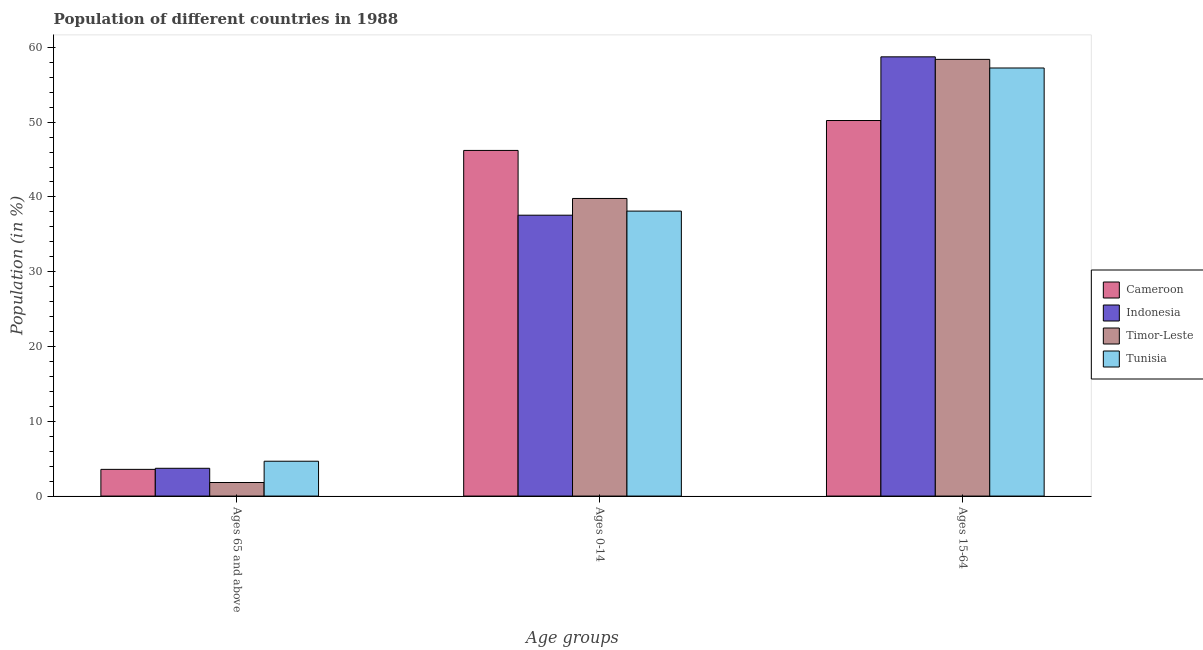How many different coloured bars are there?
Offer a very short reply. 4. How many groups of bars are there?
Offer a terse response. 3. How many bars are there on the 2nd tick from the left?
Ensure brevity in your answer.  4. What is the label of the 2nd group of bars from the left?
Offer a terse response. Ages 0-14. What is the percentage of population within the age-group 0-14 in Cameroon?
Your answer should be compact. 46.22. Across all countries, what is the maximum percentage of population within the age-group 0-14?
Provide a succinct answer. 46.22. Across all countries, what is the minimum percentage of population within the age-group of 65 and above?
Offer a very short reply. 1.81. In which country was the percentage of population within the age-group 15-64 maximum?
Offer a terse response. Indonesia. What is the total percentage of population within the age-group 0-14 in the graph?
Provide a short and direct response. 161.67. What is the difference between the percentage of population within the age-group 0-14 in Indonesia and that in Timor-Leste?
Make the answer very short. -2.24. What is the difference between the percentage of population within the age-group 15-64 in Tunisia and the percentage of population within the age-group of 65 and above in Cameroon?
Your answer should be very brief. 53.67. What is the average percentage of population within the age-group of 65 and above per country?
Ensure brevity in your answer.  3.44. What is the difference between the percentage of population within the age-group 0-14 and percentage of population within the age-group 15-64 in Cameroon?
Provide a succinct answer. -4. What is the ratio of the percentage of population within the age-group 0-14 in Tunisia to that in Timor-Leste?
Offer a very short reply. 0.96. Is the percentage of population within the age-group 15-64 in Tunisia less than that in Indonesia?
Make the answer very short. Yes. What is the difference between the highest and the second highest percentage of population within the age-group 15-64?
Ensure brevity in your answer.  0.34. What is the difference between the highest and the lowest percentage of population within the age-group 15-64?
Your response must be concise. 8.52. Is the sum of the percentage of population within the age-group of 65 and above in Cameroon and Tunisia greater than the maximum percentage of population within the age-group 15-64 across all countries?
Offer a very short reply. No. What does the 4th bar from the left in Ages 0-14 represents?
Your response must be concise. Tunisia. What does the 2nd bar from the right in Ages 15-64 represents?
Provide a short and direct response. Timor-Leste. How many bars are there?
Your answer should be compact. 12. Does the graph contain grids?
Give a very brief answer. No. How are the legend labels stacked?
Offer a very short reply. Vertical. What is the title of the graph?
Your answer should be very brief. Population of different countries in 1988. Does "Upper middle income" appear as one of the legend labels in the graph?
Make the answer very short. No. What is the label or title of the X-axis?
Give a very brief answer. Age groups. What is the Population (in %) in Cameroon in Ages 65 and above?
Offer a very short reply. 3.57. What is the Population (in %) in Indonesia in Ages 65 and above?
Make the answer very short. 3.71. What is the Population (in %) of Timor-Leste in Ages 65 and above?
Your answer should be very brief. 1.81. What is the Population (in %) of Tunisia in Ages 65 and above?
Your answer should be very brief. 4.66. What is the Population (in %) of Cameroon in Ages 0-14?
Make the answer very short. 46.22. What is the Population (in %) of Indonesia in Ages 0-14?
Your response must be concise. 37.56. What is the Population (in %) in Timor-Leste in Ages 0-14?
Give a very brief answer. 39.79. What is the Population (in %) of Tunisia in Ages 0-14?
Your answer should be compact. 38.1. What is the Population (in %) of Cameroon in Ages 15-64?
Give a very brief answer. 50.21. What is the Population (in %) in Indonesia in Ages 15-64?
Keep it short and to the point. 58.73. What is the Population (in %) of Timor-Leste in Ages 15-64?
Your answer should be very brief. 58.39. What is the Population (in %) in Tunisia in Ages 15-64?
Make the answer very short. 57.24. Across all Age groups, what is the maximum Population (in %) in Cameroon?
Keep it short and to the point. 50.21. Across all Age groups, what is the maximum Population (in %) in Indonesia?
Provide a short and direct response. 58.73. Across all Age groups, what is the maximum Population (in %) in Timor-Leste?
Your answer should be compact. 58.39. Across all Age groups, what is the maximum Population (in %) in Tunisia?
Your answer should be very brief. 57.24. Across all Age groups, what is the minimum Population (in %) of Cameroon?
Provide a short and direct response. 3.57. Across all Age groups, what is the minimum Population (in %) of Indonesia?
Your answer should be compact. 3.71. Across all Age groups, what is the minimum Population (in %) of Timor-Leste?
Your answer should be compact. 1.81. Across all Age groups, what is the minimum Population (in %) in Tunisia?
Your answer should be compact. 4.66. What is the total Population (in %) in Cameroon in the graph?
Your response must be concise. 100. What is the difference between the Population (in %) in Cameroon in Ages 65 and above and that in Ages 0-14?
Your response must be concise. -42.65. What is the difference between the Population (in %) of Indonesia in Ages 65 and above and that in Ages 0-14?
Keep it short and to the point. -33.84. What is the difference between the Population (in %) in Timor-Leste in Ages 65 and above and that in Ages 0-14?
Give a very brief answer. -37.98. What is the difference between the Population (in %) in Tunisia in Ages 65 and above and that in Ages 0-14?
Provide a succinct answer. -33.44. What is the difference between the Population (in %) in Cameroon in Ages 65 and above and that in Ages 15-64?
Offer a very short reply. -46.65. What is the difference between the Population (in %) of Indonesia in Ages 65 and above and that in Ages 15-64?
Your answer should be very brief. -55.02. What is the difference between the Population (in %) of Timor-Leste in Ages 65 and above and that in Ages 15-64?
Provide a succinct answer. -56.58. What is the difference between the Population (in %) of Tunisia in Ages 65 and above and that in Ages 15-64?
Provide a short and direct response. -52.58. What is the difference between the Population (in %) in Cameroon in Ages 0-14 and that in Ages 15-64?
Provide a succinct answer. -4. What is the difference between the Population (in %) of Indonesia in Ages 0-14 and that in Ages 15-64?
Your response must be concise. -21.17. What is the difference between the Population (in %) in Timor-Leste in Ages 0-14 and that in Ages 15-64?
Make the answer very short. -18.6. What is the difference between the Population (in %) in Tunisia in Ages 0-14 and that in Ages 15-64?
Offer a very short reply. -19.13. What is the difference between the Population (in %) of Cameroon in Ages 65 and above and the Population (in %) of Indonesia in Ages 0-14?
Make the answer very short. -33.99. What is the difference between the Population (in %) in Cameroon in Ages 65 and above and the Population (in %) in Timor-Leste in Ages 0-14?
Provide a short and direct response. -36.22. What is the difference between the Population (in %) in Cameroon in Ages 65 and above and the Population (in %) in Tunisia in Ages 0-14?
Your answer should be very brief. -34.53. What is the difference between the Population (in %) in Indonesia in Ages 65 and above and the Population (in %) in Timor-Leste in Ages 0-14?
Ensure brevity in your answer.  -36.08. What is the difference between the Population (in %) in Indonesia in Ages 65 and above and the Population (in %) in Tunisia in Ages 0-14?
Offer a very short reply. -34.39. What is the difference between the Population (in %) of Timor-Leste in Ages 65 and above and the Population (in %) of Tunisia in Ages 0-14?
Your answer should be compact. -36.29. What is the difference between the Population (in %) in Cameroon in Ages 65 and above and the Population (in %) in Indonesia in Ages 15-64?
Make the answer very short. -55.16. What is the difference between the Population (in %) of Cameroon in Ages 65 and above and the Population (in %) of Timor-Leste in Ages 15-64?
Ensure brevity in your answer.  -54.82. What is the difference between the Population (in %) in Cameroon in Ages 65 and above and the Population (in %) in Tunisia in Ages 15-64?
Your answer should be compact. -53.67. What is the difference between the Population (in %) of Indonesia in Ages 65 and above and the Population (in %) of Timor-Leste in Ages 15-64?
Your answer should be compact. -54.68. What is the difference between the Population (in %) in Indonesia in Ages 65 and above and the Population (in %) in Tunisia in Ages 15-64?
Offer a very short reply. -53.52. What is the difference between the Population (in %) of Timor-Leste in Ages 65 and above and the Population (in %) of Tunisia in Ages 15-64?
Keep it short and to the point. -55.42. What is the difference between the Population (in %) of Cameroon in Ages 0-14 and the Population (in %) of Indonesia in Ages 15-64?
Make the answer very short. -12.51. What is the difference between the Population (in %) of Cameroon in Ages 0-14 and the Population (in %) of Timor-Leste in Ages 15-64?
Provide a short and direct response. -12.18. What is the difference between the Population (in %) of Cameroon in Ages 0-14 and the Population (in %) of Tunisia in Ages 15-64?
Your answer should be very brief. -11.02. What is the difference between the Population (in %) in Indonesia in Ages 0-14 and the Population (in %) in Timor-Leste in Ages 15-64?
Provide a succinct answer. -20.84. What is the difference between the Population (in %) in Indonesia in Ages 0-14 and the Population (in %) in Tunisia in Ages 15-64?
Make the answer very short. -19.68. What is the difference between the Population (in %) of Timor-Leste in Ages 0-14 and the Population (in %) of Tunisia in Ages 15-64?
Provide a succinct answer. -17.44. What is the average Population (in %) in Cameroon per Age groups?
Your response must be concise. 33.33. What is the average Population (in %) of Indonesia per Age groups?
Your answer should be very brief. 33.33. What is the average Population (in %) in Timor-Leste per Age groups?
Your answer should be very brief. 33.33. What is the average Population (in %) of Tunisia per Age groups?
Make the answer very short. 33.33. What is the difference between the Population (in %) of Cameroon and Population (in %) of Indonesia in Ages 65 and above?
Provide a succinct answer. -0.14. What is the difference between the Population (in %) of Cameroon and Population (in %) of Timor-Leste in Ages 65 and above?
Your response must be concise. 1.76. What is the difference between the Population (in %) of Cameroon and Population (in %) of Tunisia in Ages 65 and above?
Provide a short and direct response. -1.09. What is the difference between the Population (in %) of Indonesia and Population (in %) of Timor-Leste in Ages 65 and above?
Make the answer very short. 1.9. What is the difference between the Population (in %) in Indonesia and Population (in %) in Tunisia in Ages 65 and above?
Offer a terse response. -0.95. What is the difference between the Population (in %) in Timor-Leste and Population (in %) in Tunisia in Ages 65 and above?
Your answer should be very brief. -2.85. What is the difference between the Population (in %) in Cameroon and Population (in %) in Indonesia in Ages 0-14?
Provide a short and direct response. 8.66. What is the difference between the Population (in %) of Cameroon and Population (in %) of Timor-Leste in Ages 0-14?
Make the answer very short. 6.42. What is the difference between the Population (in %) in Cameroon and Population (in %) in Tunisia in Ages 0-14?
Make the answer very short. 8.11. What is the difference between the Population (in %) of Indonesia and Population (in %) of Timor-Leste in Ages 0-14?
Offer a terse response. -2.24. What is the difference between the Population (in %) of Indonesia and Population (in %) of Tunisia in Ages 0-14?
Your answer should be very brief. -0.55. What is the difference between the Population (in %) of Timor-Leste and Population (in %) of Tunisia in Ages 0-14?
Your answer should be compact. 1.69. What is the difference between the Population (in %) in Cameroon and Population (in %) in Indonesia in Ages 15-64?
Your answer should be very brief. -8.52. What is the difference between the Population (in %) of Cameroon and Population (in %) of Timor-Leste in Ages 15-64?
Offer a terse response. -8.18. What is the difference between the Population (in %) in Cameroon and Population (in %) in Tunisia in Ages 15-64?
Offer a very short reply. -7.02. What is the difference between the Population (in %) in Indonesia and Population (in %) in Timor-Leste in Ages 15-64?
Keep it short and to the point. 0.34. What is the difference between the Population (in %) in Indonesia and Population (in %) in Tunisia in Ages 15-64?
Your response must be concise. 1.49. What is the difference between the Population (in %) in Timor-Leste and Population (in %) in Tunisia in Ages 15-64?
Offer a terse response. 1.15. What is the ratio of the Population (in %) of Cameroon in Ages 65 and above to that in Ages 0-14?
Provide a short and direct response. 0.08. What is the ratio of the Population (in %) in Indonesia in Ages 65 and above to that in Ages 0-14?
Provide a succinct answer. 0.1. What is the ratio of the Population (in %) in Timor-Leste in Ages 65 and above to that in Ages 0-14?
Your answer should be compact. 0.05. What is the ratio of the Population (in %) in Tunisia in Ages 65 and above to that in Ages 0-14?
Provide a succinct answer. 0.12. What is the ratio of the Population (in %) in Cameroon in Ages 65 and above to that in Ages 15-64?
Your answer should be very brief. 0.07. What is the ratio of the Population (in %) in Indonesia in Ages 65 and above to that in Ages 15-64?
Offer a terse response. 0.06. What is the ratio of the Population (in %) in Timor-Leste in Ages 65 and above to that in Ages 15-64?
Give a very brief answer. 0.03. What is the ratio of the Population (in %) of Tunisia in Ages 65 and above to that in Ages 15-64?
Your response must be concise. 0.08. What is the ratio of the Population (in %) of Cameroon in Ages 0-14 to that in Ages 15-64?
Your answer should be very brief. 0.92. What is the ratio of the Population (in %) of Indonesia in Ages 0-14 to that in Ages 15-64?
Keep it short and to the point. 0.64. What is the ratio of the Population (in %) of Timor-Leste in Ages 0-14 to that in Ages 15-64?
Your answer should be compact. 0.68. What is the ratio of the Population (in %) of Tunisia in Ages 0-14 to that in Ages 15-64?
Keep it short and to the point. 0.67. What is the difference between the highest and the second highest Population (in %) in Cameroon?
Keep it short and to the point. 4. What is the difference between the highest and the second highest Population (in %) in Indonesia?
Keep it short and to the point. 21.17. What is the difference between the highest and the second highest Population (in %) of Timor-Leste?
Offer a very short reply. 18.6. What is the difference between the highest and the second highest Population (in %) in Tunisia?
Make the answer very short. 19.13. What is the difference between the highest and the lowest Population (in %) in Cameroon?
Your response must be concise. 46.65. What is the difference between the highest and the lowest Population (in %) of Indonesia?
Your answer should be very brief. 55.02. What is the difference between the highest and the lowest Population (in %) in Timor-Leste?
Ensure brevity in your answer.  56.58. What is the difference between the highest and the lowest Population (in %) of Tunisia?
Ensure brevity in your answer.  52.58. 